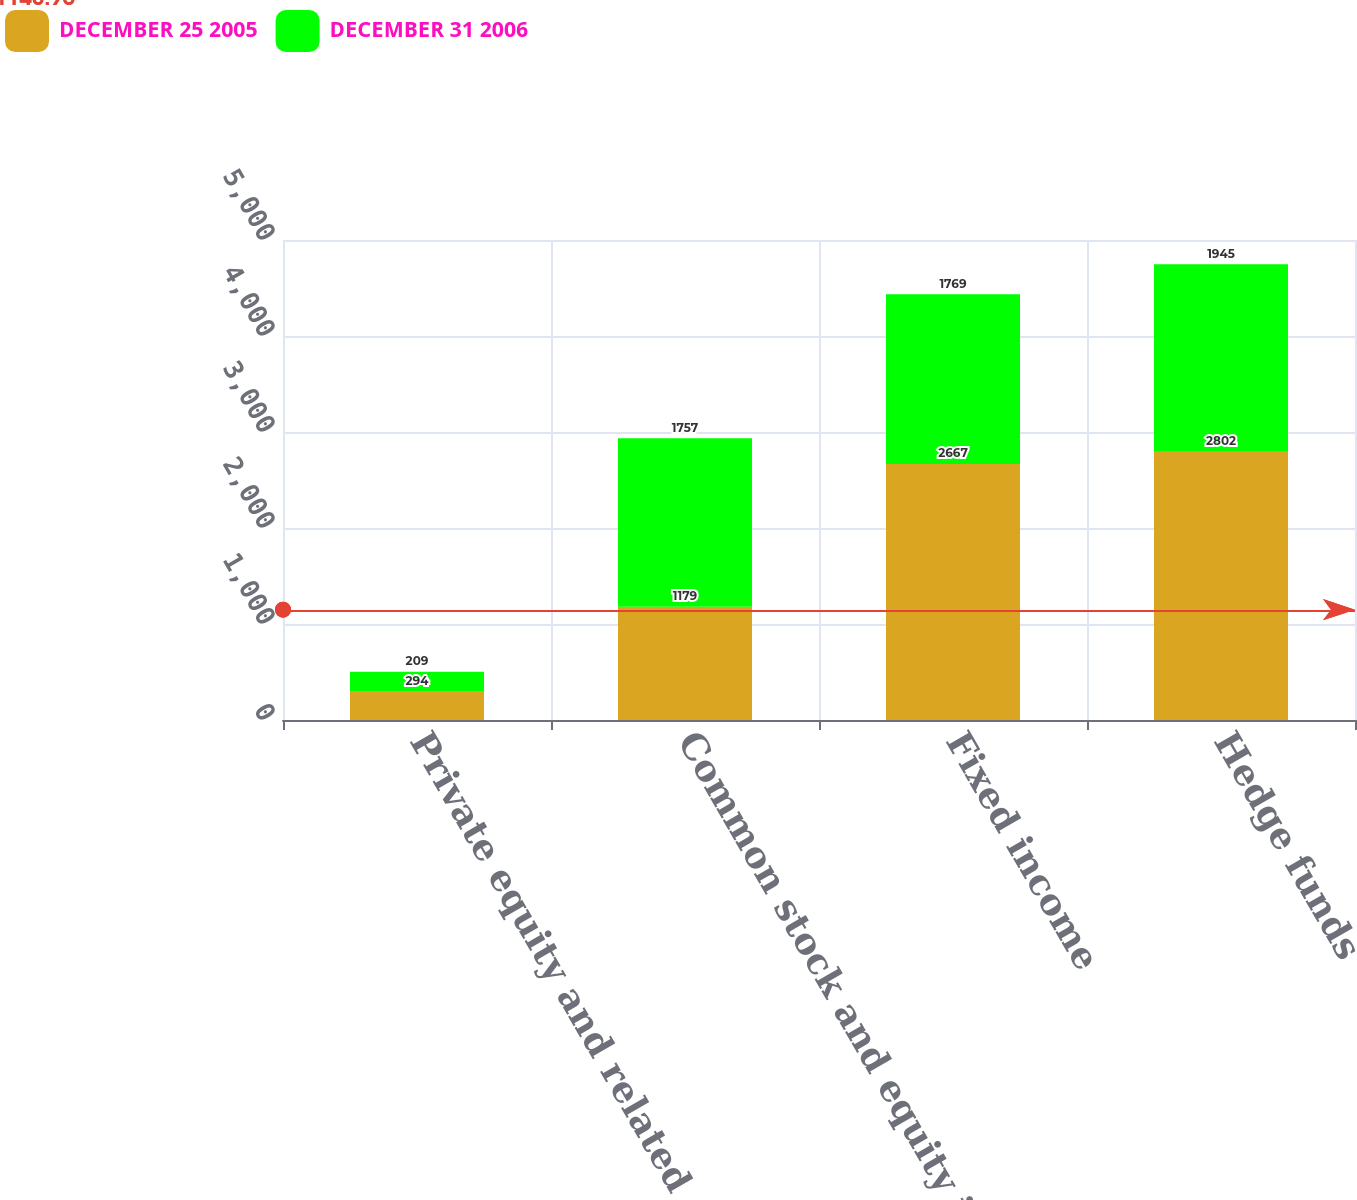Convert chart to OTSL. <chart><loc_0><loc_0><loc_500><loc_500><stacked_bar_chart><ecel><fcel>Private equity and related<fcel>Common stock and equity index<fcel>Fixed income<fcel>Hedge funds<nl><fcel>DECEMBER 25 2005<fcel>294<fcel>1179<fcel>2667<fcel>2802<nl><fcel>DECEMBER 31 2006<fcel>209<fcel>1757<fcel>1769<fcel>1945<nl></chart> 